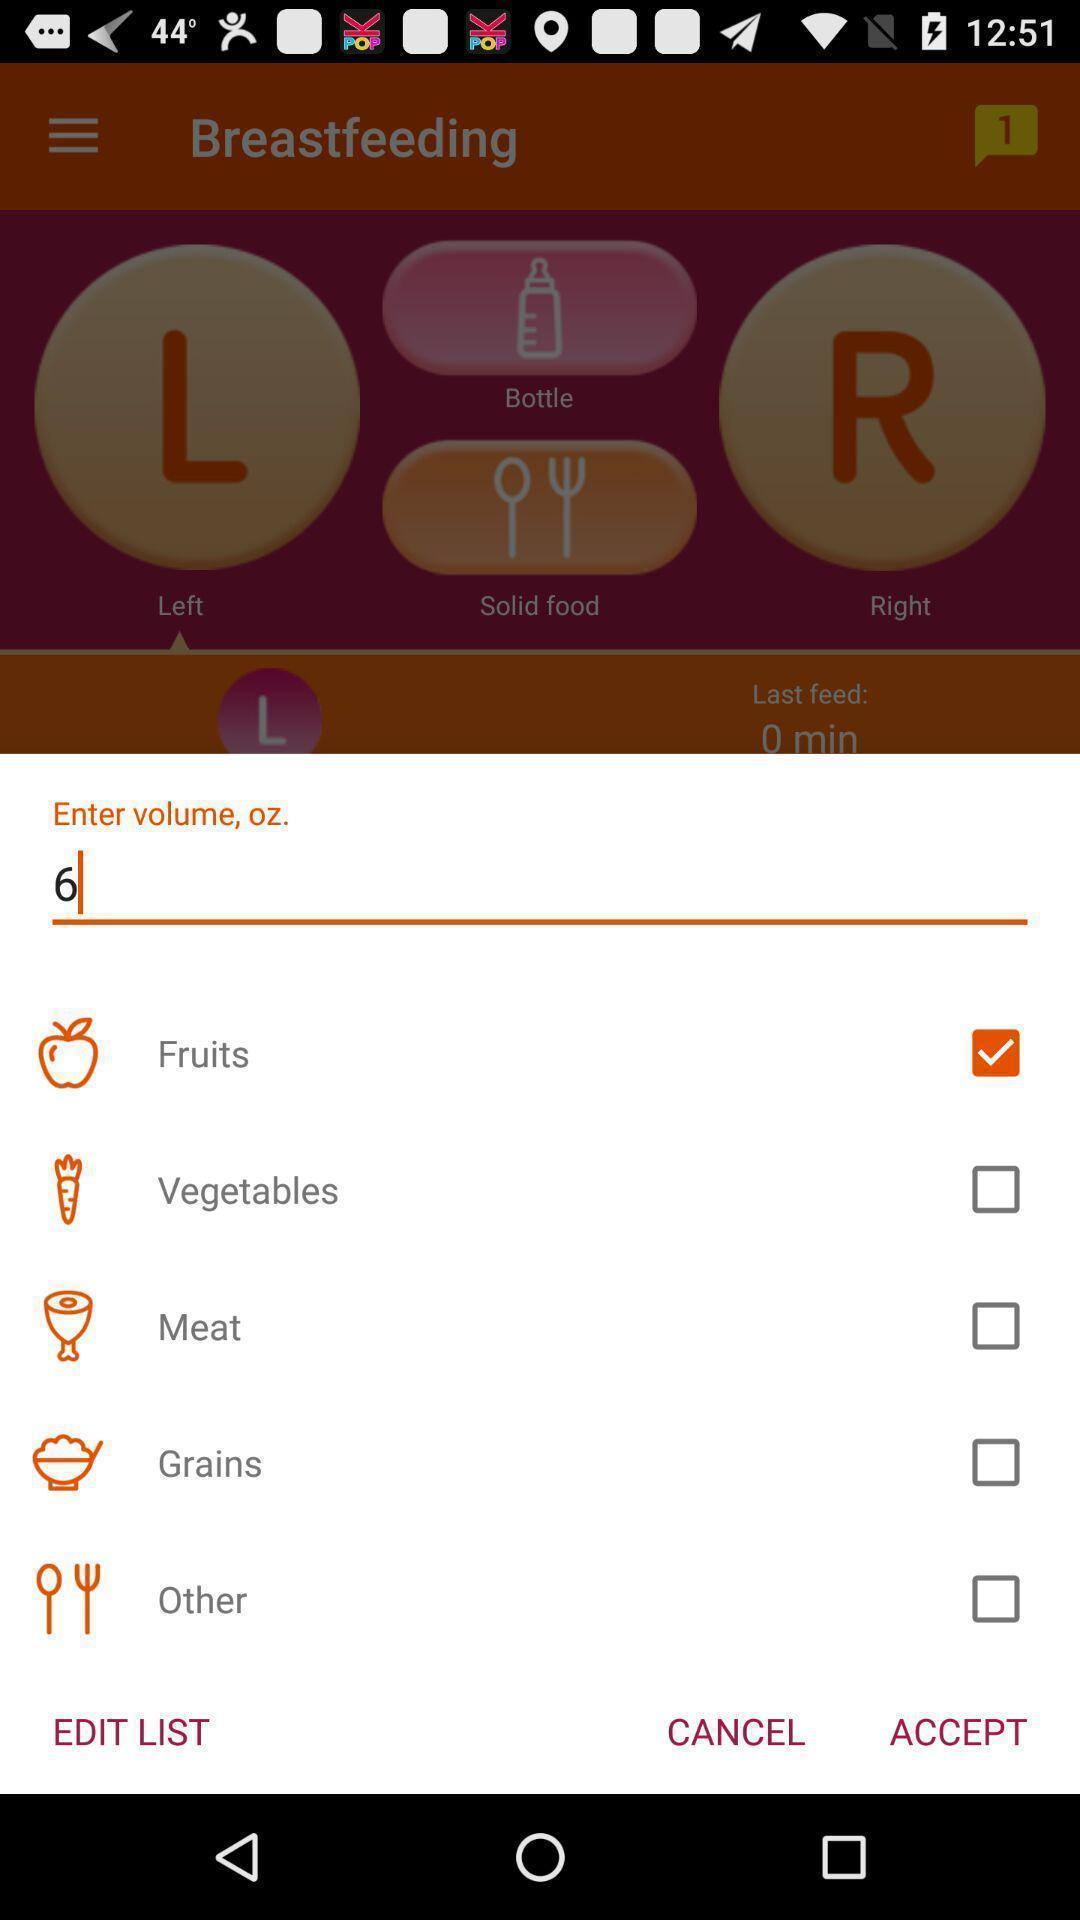Please provide a description for this image. Push up showing list of food items. 